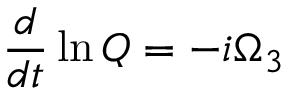Convert formula to latex. <formula><loc_0><loc_0><loc_500><loc_500>\frac { d } { d t } \ln Q = - i \Omega _ { 3 }</formula> 